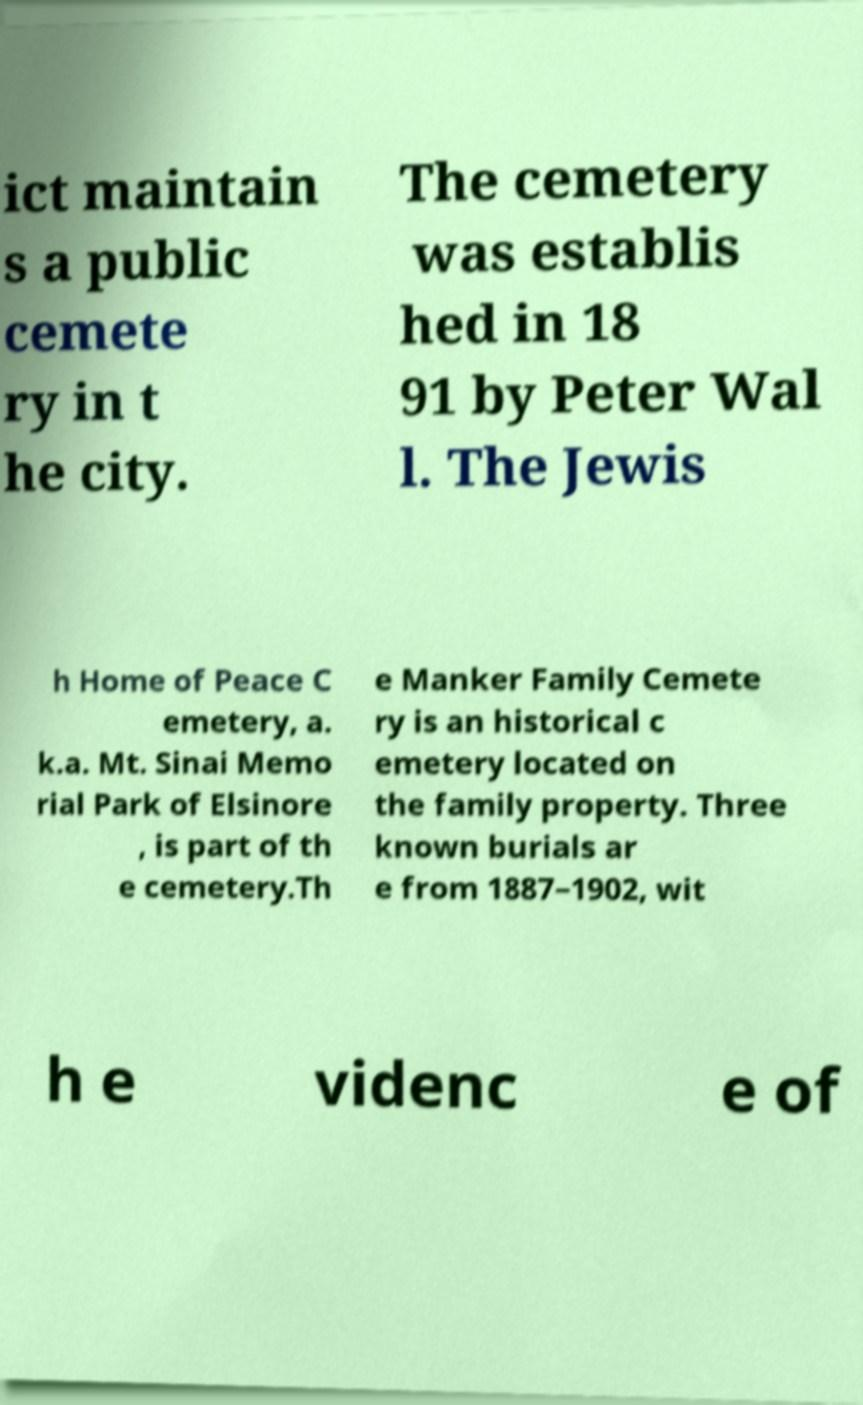Could you assist in decoding the text presented in this image and type it out clearly? ict maintain s a public cemete ry in t he city. The cemetery was establis hed in 18 91 by Peter Wal l. The Jewis h Home of Peace C emetery, a. k.a. Mt. Sinai Memo rial Park of Elsinore , is part of th e cemetery.Th e Manker Family Cemete ry is an historical c emetery located on the family property. Three known burials ar e from 1887–1902, wit h e videnc e of 